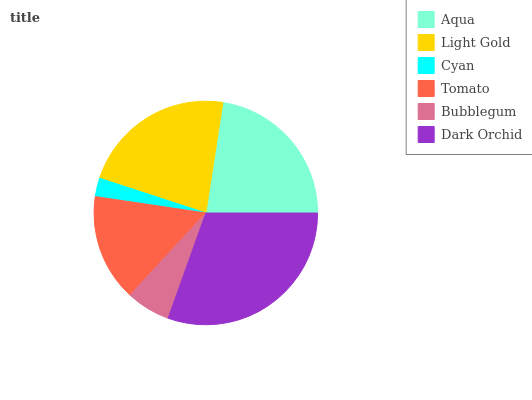Is Cyan the minimum?
Answer yes or no. Yes. Is Dark Orchid the maximum?
Answer yes or no. Yes. Is Light Gold the minimum?
Answer yes or no. No. Is Light Gold the maximum?
Answer yes or no. No. Is Aqua greater than Light Gold?
Answer yes or no. Yes. Is Light Gold less than Aqua?
Answer yes or no. Yes. Is Light Gold greater than Aqua?
Answer yes or no. No. Is Aqua less than Light Gold?
Answer yes or no. No. Is Light Gold the high median?
Answer yes or no. Yes. Is Tomato the low median?
Answer yes or no. Yes. Is Cyan the high median?
Answer yes or no. No. Is Aqua the low median?
Answer yes or no. No. 